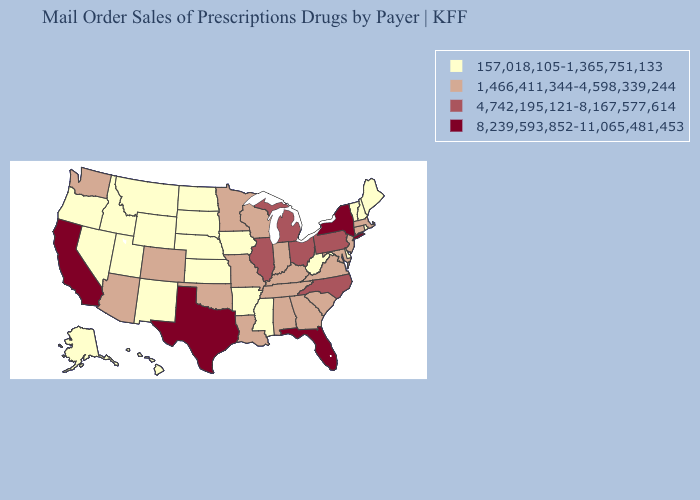Among the states that border Georgia , does Florida have the lowest value?
Quick response, please. No. Does Illinois have the lowest value in the MidWest?
Keep it brief. No. What is the value of Illinois?
Give a very brief answer. 4,742,195,121-8,167,577,614. Is the legend a continuous bar?
Write a very short answer. No. Which states hav the highest value in the West?
Keep it brief. California. Name the states that have a value in the range 1,466,411,344-4,598,339,244?
Keep it brief. Alabama, Arizona, Colorado, Connecticut, Georgia, Indiana, Kentucky, Louisiana, Maryland, Massachusetts, Minnesota, Missouri, New Jersey, Oklahoma, South Carolina, Tennessee, Virginia, Washington, Wisconsin. What is the value of North Dakota?
Write a very short answer. 157,018,105-1,365,751,133. What is the value of Maine?
Write a very short answer. 157,018,105-1,365,751,133. Name the states that have a value in the range 157,018,105-1,365,751,133?
Concise answer only. Alaska, Arkansas, Delaware, Hawaii, Idaho, Iowa, Kansas, Maine, Mississippi, Montana, Nebraska, Nevada, New Hampshire, New Mexico, North Dakota, Oregon, Rhode Island, South Dakota, Utah, Vermont, West Virginia, Wyoming. Which states have the highest value in the USA?
Concise answer only. California, Florida, New York, Texas. Does Michigan have a higher value than Montana?
Keep it brief. Yes. Which states have the lowest value in the South?
Give a very brief answer. Arkansas, Delaware, Mississippi, West Virginia. Name the states that have a value in the range 1,466,411,344-4,598,339,244?
Write a very short answer. Alabama, Arizona, Colorado, Connecticut, Georgia, Indiana, Kentucky, Louisiana, Maryland, Massachusetts, Minnesota, Missouri, New Jersey, Oklahoma, South Carolina, Tennessee, Virginia, Washington, Wisconsin. Among the states that border Delaware , does Pennsylvania have the lowest value?
Write a very short answer. No. Name the states that have a value in the range 8,239,593,852-11,065,481,453?
Short answer required. California, Florida, New York, Texas. 